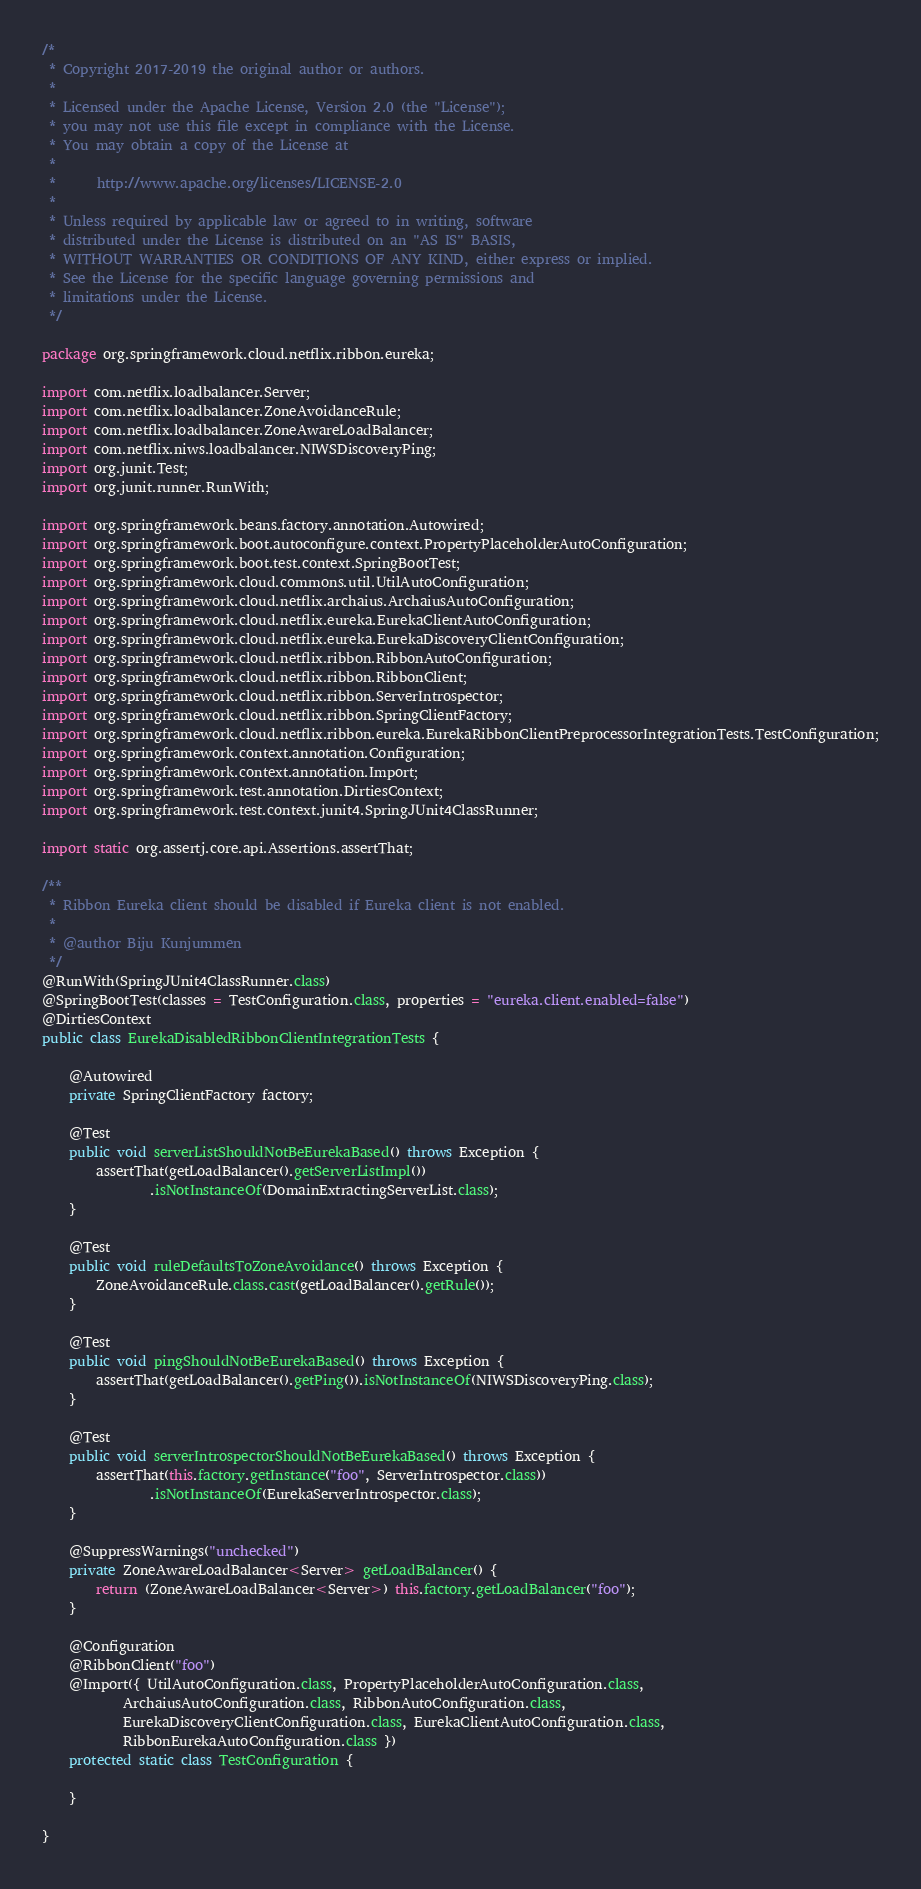Convert code to text. <code><loc_0><loc_0><loc_500><loc_500><_Java_>/*
 * Copyright 2017-2019 the original author or authors.
 *
 * Licensed under the Apache License, Version 2.0 (the "License");
 * you may not use this file except in compliance with the License.
 * You may obtain a copy of the License at
 *
 *      http://www.apache.org/licenses/LICENSE-2.0
 *
 * Unless required by applicable law or agreed to in writing, software
 * distributed under the License is distributed on an "AS IS" BASIS,
 * WITHOUT WARRANTIES OR CONDITIONS OF ANY KIND, either express or implied.
 * See the License for the specific language governing permissions and
 * limitations under the License.
 */

package org.springframework.cloud.netflix.ribbon.eureka;

import com.netflix.loadbalancer.Server;
import com.netflix.loadbalancer.ZoneAvoidanceRule;
import com.netflix.loadbalancer.ZoneAwareLoadBalancer;
import com.netflix.niws.loadbalancer.NIWSDiscoveryPing;
import org.junit.Test;
import org.junit.runner.RunWith;

import org.springframework.beans.factory.annotation.Autowired;
import org.springframework.boot.autoconfigure.context.PropertyPlaceholderAutoConfiguration;
import org.springframework.boot.test.context.SpringBootTest;
import org.springframework.cloud.commons.util.UtilAutoConfiguration;
import org.springframework.cloud.netflix.archaius.ArchaiusAutoConfiguration;
import org.springframework.cloud.netflix.eureka.EurekaClientAutoConfiguration;
import org.springframework.cloud.netflix.eureka.EurekaDiscoveryClientConfiguration;
import org.springframework.cloud.netflix.ribbon.RibbonAutoConfiguration;
import org.springframework.cloud.netflix.ribbon.RibbonClient;
import org.springframework.cloud.netflix.ribbon.ServerIntrospector;
import org.springframework.cloud.netflix.ribbon.SpringClientFactory;
import org.springframework.cloud.netflix.ribbon.eureka.EurekaRibbonClientPreprocessorIntegrationTests.TestConfiguration;
import org.springframework.context.annotation.Configuration;
import org.springframework.context.annotation.Import;
import org.springframework.test.annotation.DirtiesContext;
import org.springframework.test.context.junit4.SpringJUnit4ClassRunner;

import static org.assertj.core.api.Assertions.assertThat;

/**
 * Ribbon Eureka client should be disabled if Eureka client is not enabled.
 *
 * @author Biju Kunjummen
 */
@RunWith(SpringJUnit4ClassRunner.class)
@SpringBootTest(classes = TestConfiguration.class, properties = "eureka.client.enabled=false")
@DirtiesContext
public class EurekaDisabledRibbonClientIntegrationTests {

	@Autowired
	private SpringClientFactory factory;

	@Test
	public void serverListShouldNotBeEurekaBased() throws Exception {
		assertThat(getLoadBalancer().getServerListImpl())
				.isNotInstanceOf(DomainExtractingServerList.class);
	}

	@Test
	public void ruleDefaultsToZoneAvoidance() throws Exception {
		ZoneAvoidanceRule.class.cast(getLoadBalancer().getRule());
	}

	@Test
	public void pingShouldNotBeEurekaBased() throws Exception {
		assertThat(getLoadBalancer().getPing()).isNotInstanceOf(NIWSDiscoveryPing.class);
	}

	@Test
	public void serverIntrospectorShouldNotBeEurekaBased() throws Exception {
		assertThat(this.factory.getInstance("foo", ServerIntrospector.class))
				.isNotInstanceOf(EurekaServerIntrospector.class);
	}

	@SuppressWarnings("unchecked")
	private ZoneAwareLoadBalancer<Server> getLoadBalancer() {
		return (ZoneAwareLoadBalancer<Server>) this.factory.getLoadBalancer("foo");
	}

	@Configuration
	@RibbonClient("foo")
	@Import({ UtilAutoConfiguration.class, PropertyPlaceholderAutoConfiguration.class,
			ArchaiusAutoConfiguration.class, RibbonAutoConfiguration.class,
			EurekaDiscoveryClientConfiguration.class, EurekaClientAutoConfiguration.class,
			RibbonEurekaAutoConfiguration.class })
	protected static class TestConfiguration {

	}

}
</code> 